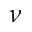Convert formula to latex. <formula><loc_0><loc_0><loc_500><loc_500>\nu</formula> 